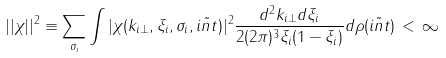<formula> <loc_0><loc_0><loc_500><loc_500>| | \chi | | ^ { 2 } \equiv \sum _ { \sigma _ { i } } \int \nolimits | \chi ( { k } _ { i \bot } , \xi _ { i } , \sigma _ { i } , \tilde { i n t } ) | ^ { 2 } \frac { d ^ { 2 } { k } _ { i \bot } d \xi _ { i } } { 2 ( 2 \pi ) ^ { 3 } \xi _ { i } ( 1 - \xi _ { i } ) } d \rho ( \tilde { i n t } ) \, < \, \infty</formula> 